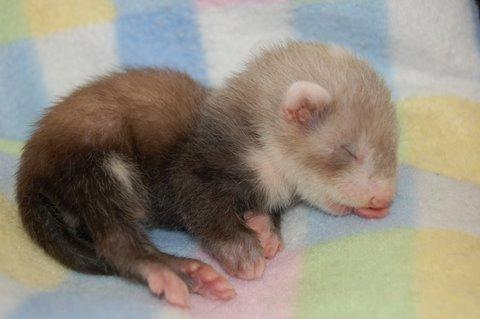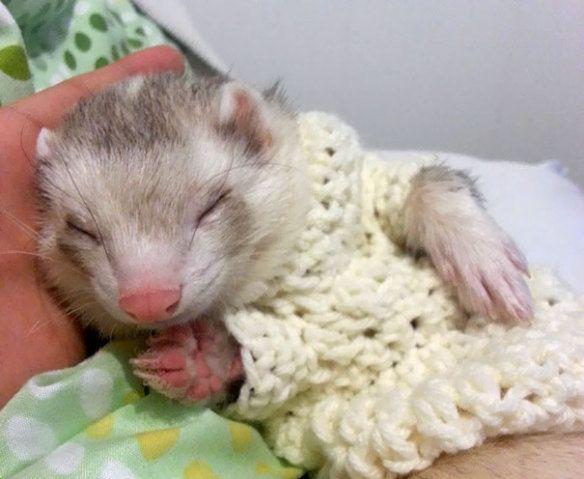The first image is the image on the left, the second image is the image on the right. Analyze the images presented: Is the assertion "At least one of the ferrets is wearing something on its head." valid? Answer yes or no. No. The first image is the image on the left, the second image is the image on the right. Analyze the images presented: Is the assertion "The left image contains one sleeping ferret." valid? Answer yes or no. Yes. 